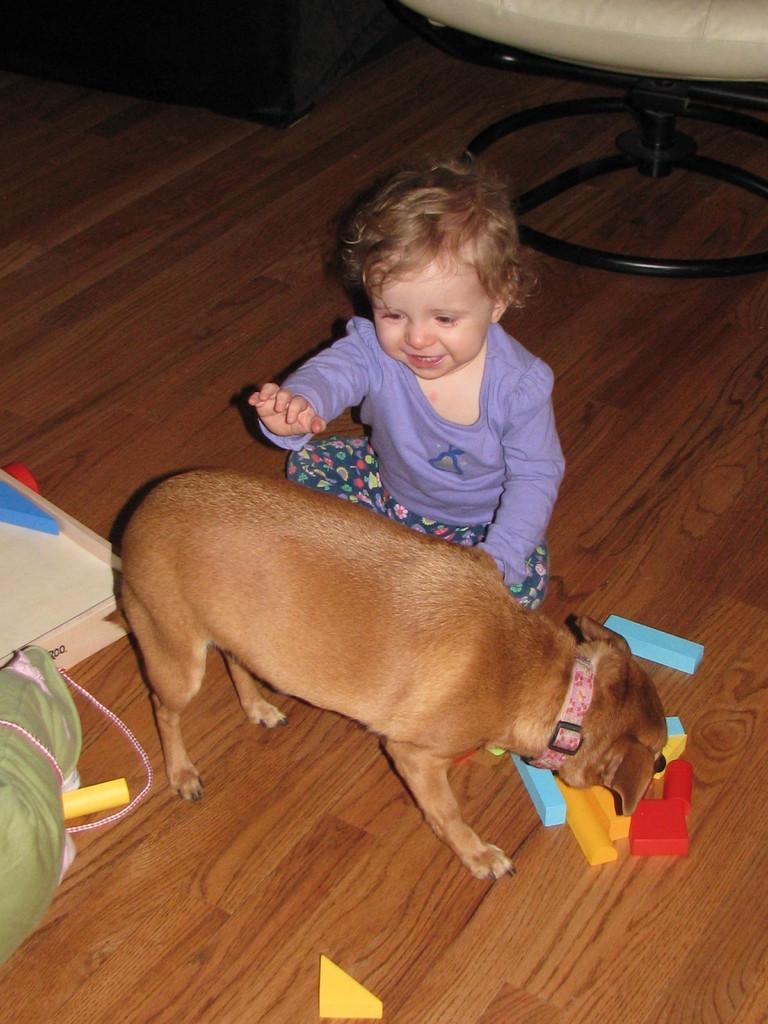Can you describe this image briefly? In this image I can see a kid sitting on the wooden floor. There is a dog, there are toys and in the top right corner it looks like a chair. Also there are some other objects. 